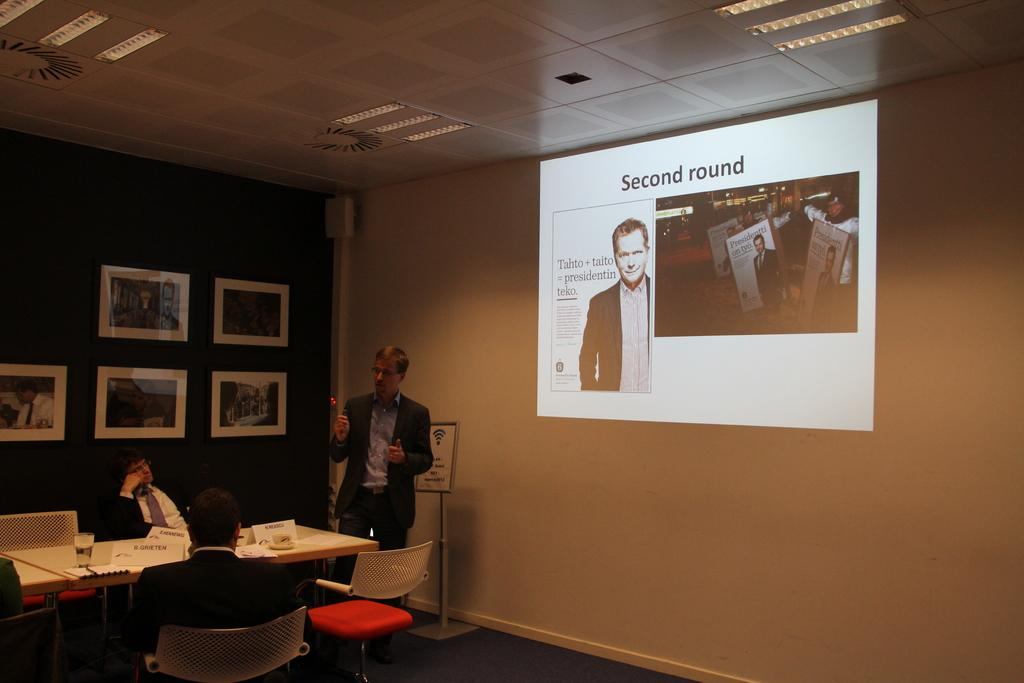What is the man in the image doing? The man is standing and giving a presentation. What can be seen behind the man? There is a screen behind the man. What are the other people in the image doing? There are men sitting at a table, and they are listening to the presentation. How many trucks can be seen in the image? There are no trucks present in the image. What type of mouth does the man giving the presentation have? The image does not provide enough detail to describe the man's mouth. 